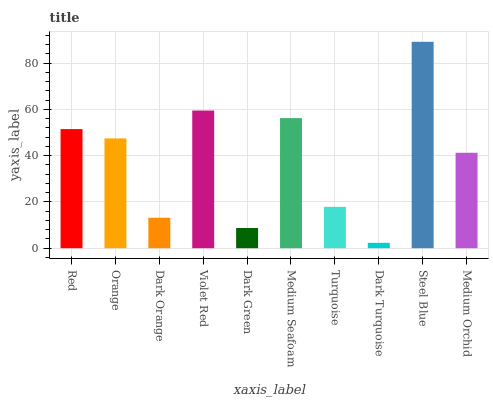Is Dark Turquoise the minimum?
Answer yes or no. Yes. Is Steel Blue the maximum?
Answer yes or no. Yes. Is Orange the minimum?
Answer yes or no. No. Is Orange the maximum?
Answer yes or no. No. Is Red greater than Orange?
Answer yes or no. Yes. Is Orange less than Red?
Answer yes or no. Yes. Is Orange greater than Red?
Answer yes or no. No. Is Red less than Orange?
Answer yes or no. No. Is Orange the high median?
Answer yes or no. Yes. Is Medium Orchid the low median?
Answer yes or no. Yes. Is Steel Blue the high median?
Answer yes or no. No. Is Medium Seafoam the low median?
Answer yes or no. No. 